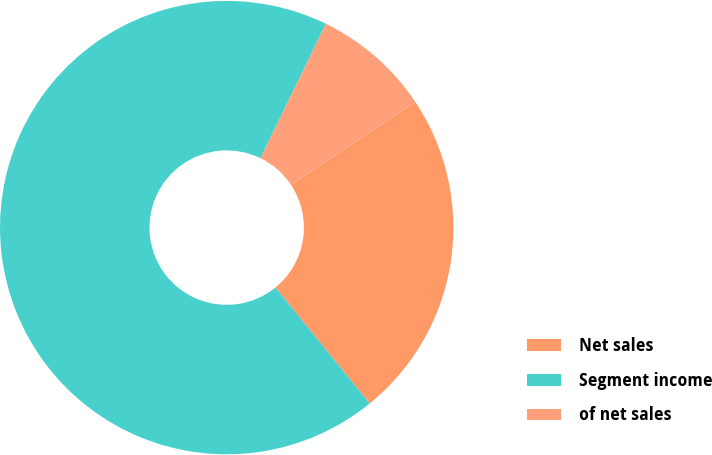Convert chart. <chart><loc_0><loc_0><loc_500><loc_500><pie_chart><fcel>Net sales<fcel>Segment income<fcel>of net sales<nl><fcel>23.49%<fcel>68.07%<fcel>8.43%<nl></chart> 